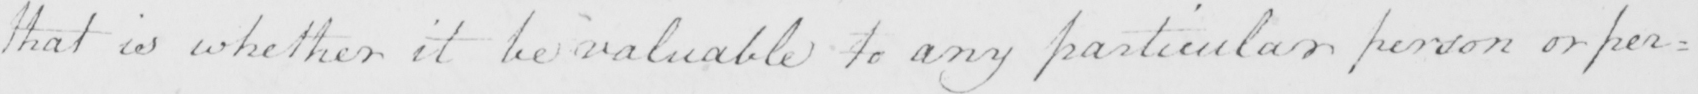What does this handwritten line say? that is whether it be valuable to any particular person or per= 